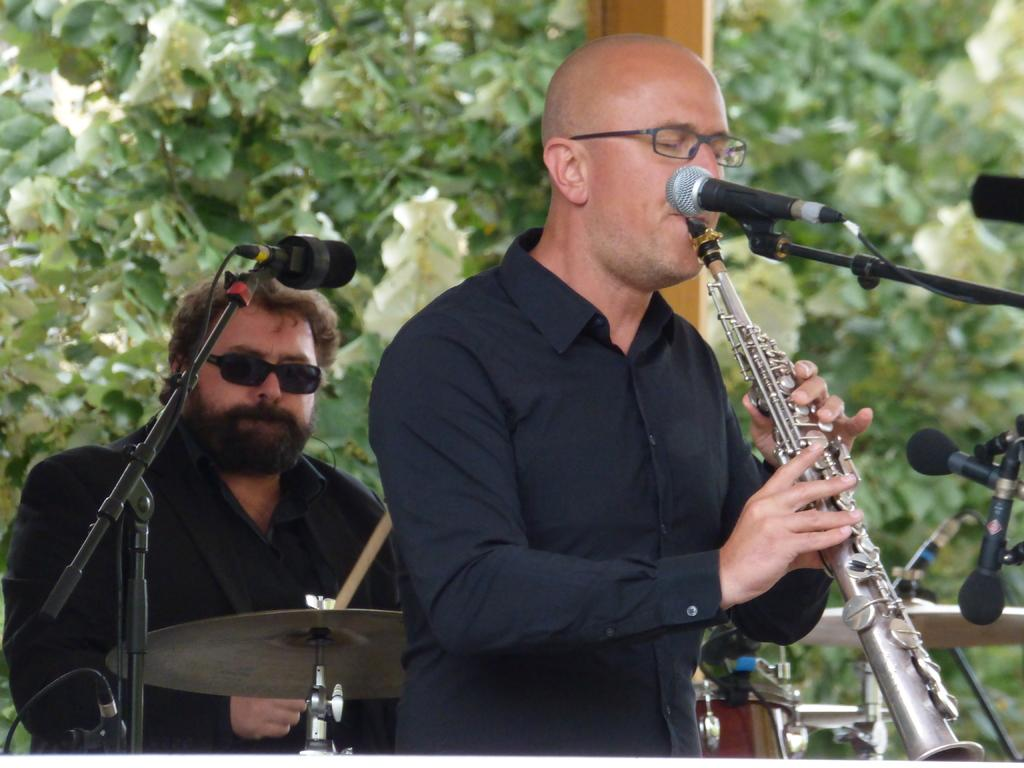How many people are in the image? There are two people in the image. What are the two people doing in the image? The two people are playing musical instruments. What object is present in front of the people? There is a microphone in front of the people. What type of blade can be seen in the image? There is no blade present in the image. Can you describe the texture of the musical instruments in the image? The provided facts do not give information about the texture of the musical instruments, so it cannot be described. 